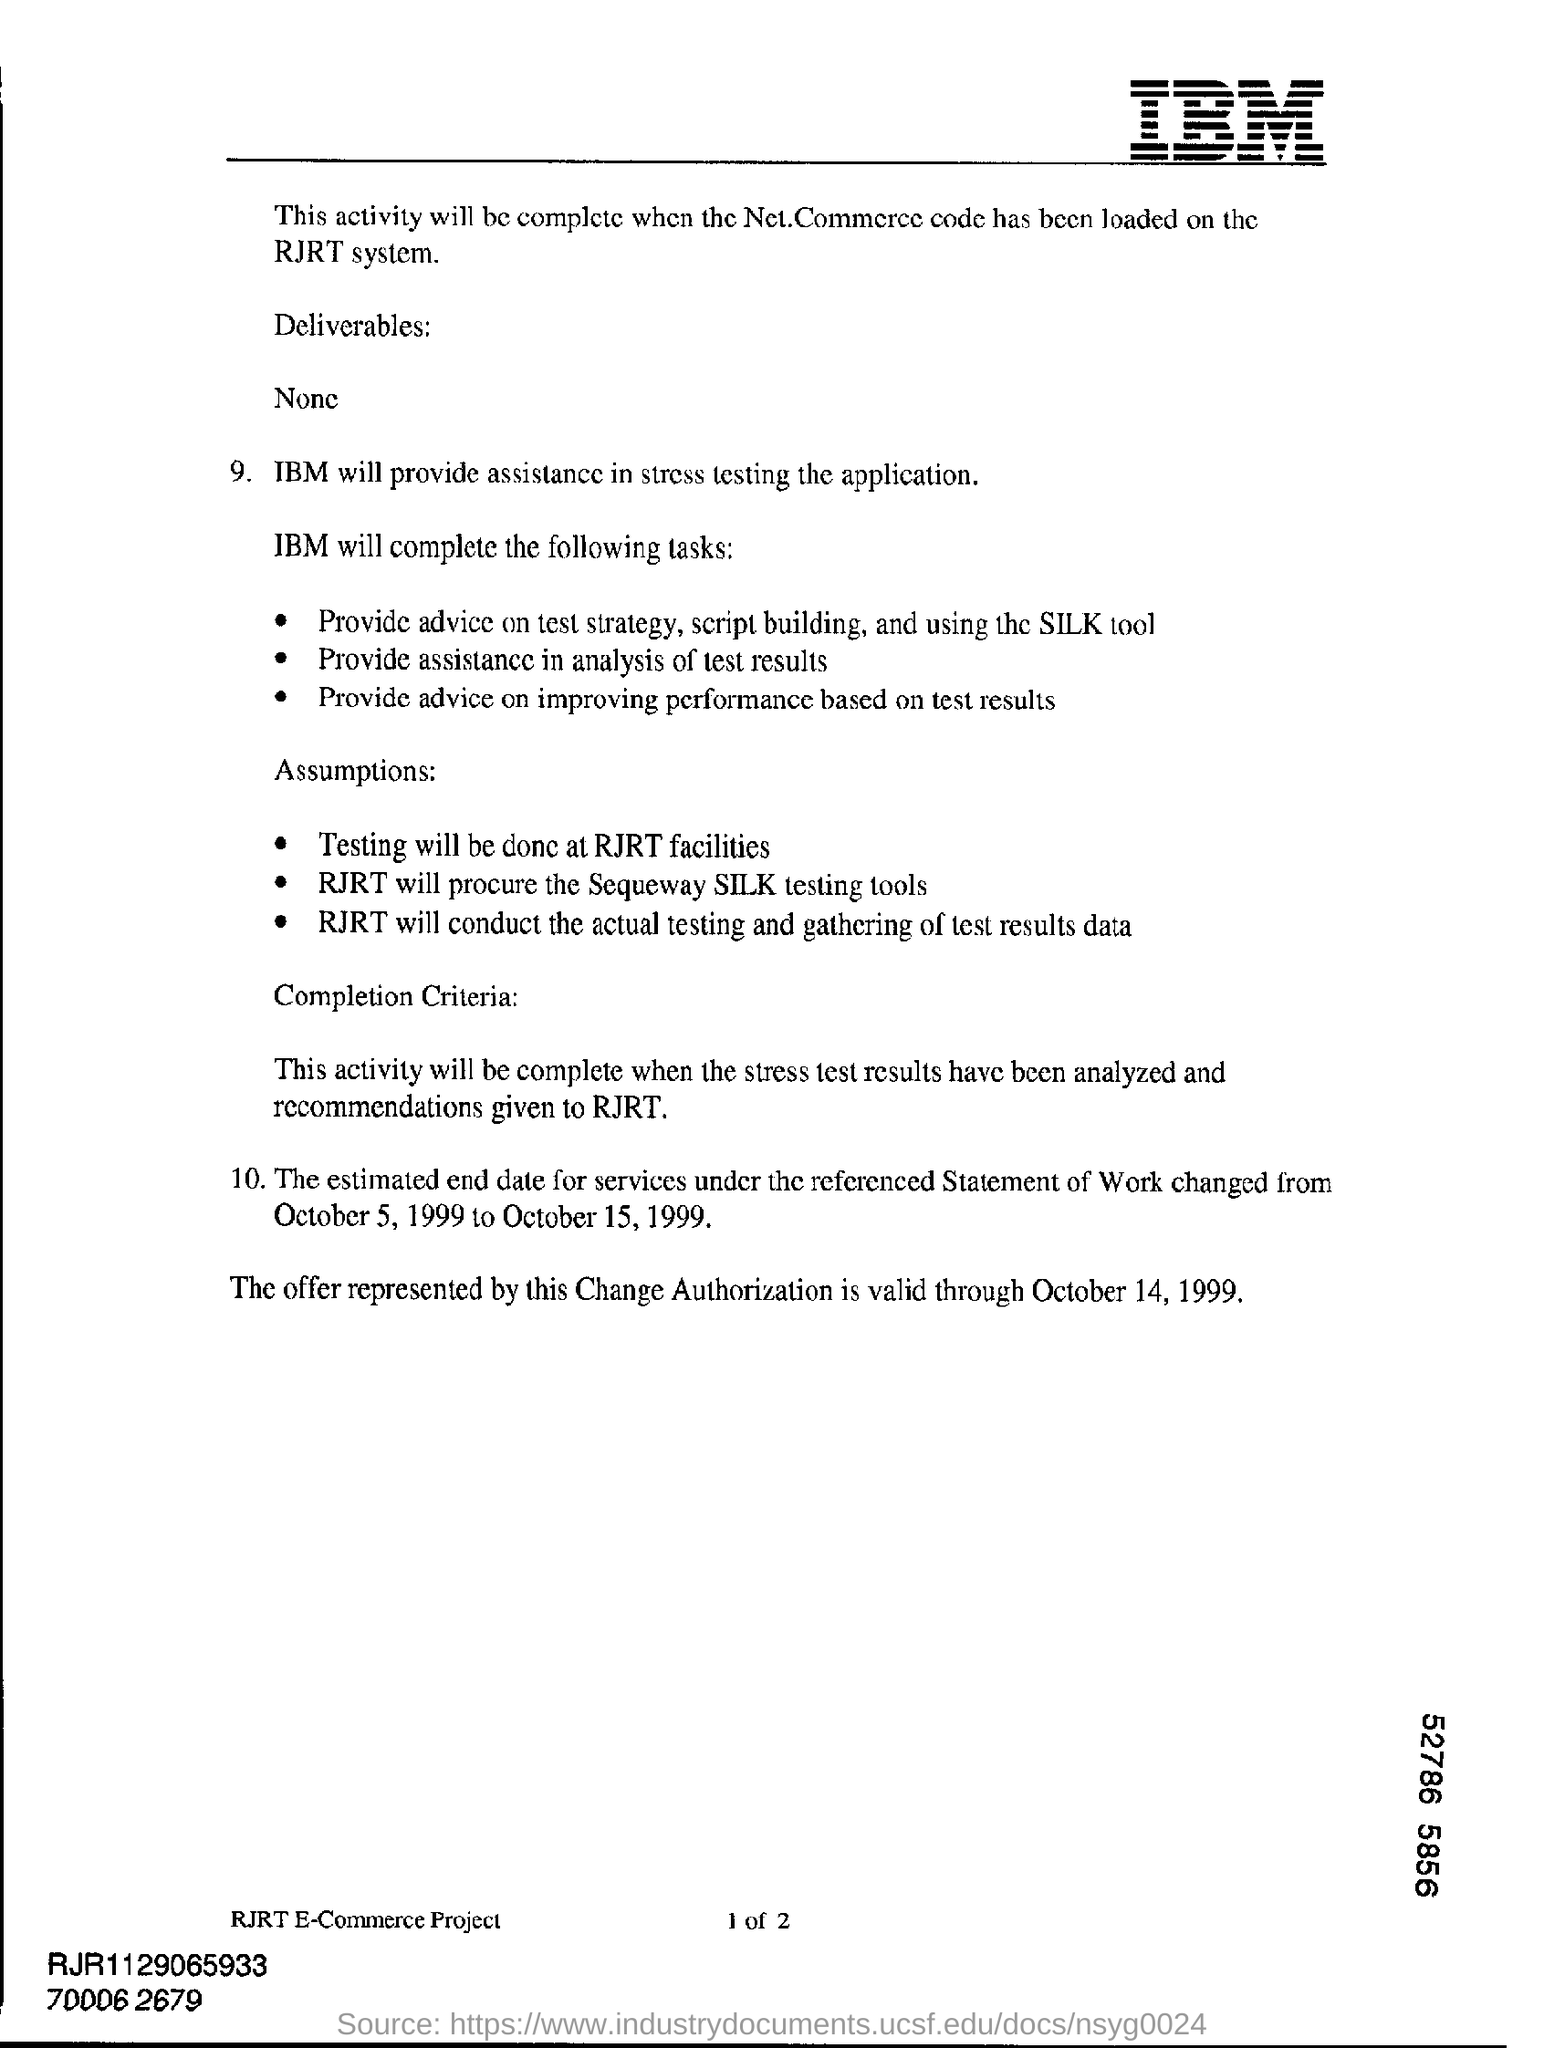What kind of assistance did ibm is providing ?
Your answer should be compact. Stress testing the application. From which date, the offer represented by this change authorization is valid ?
Ensure brevity in your answer.  October 14, 1999. 